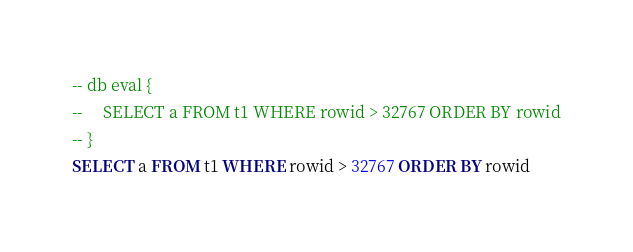<code> <loc_0><loc_0><loc_500><loc_500><_SQL_>-- db eval {
--     SELECT a FROM t1 WHERE rowid > 32767 ORDER BY rowid
-- }
SELECT a FROM t1 WHERE rowid > 32767 ORDER BY rowid</code> 